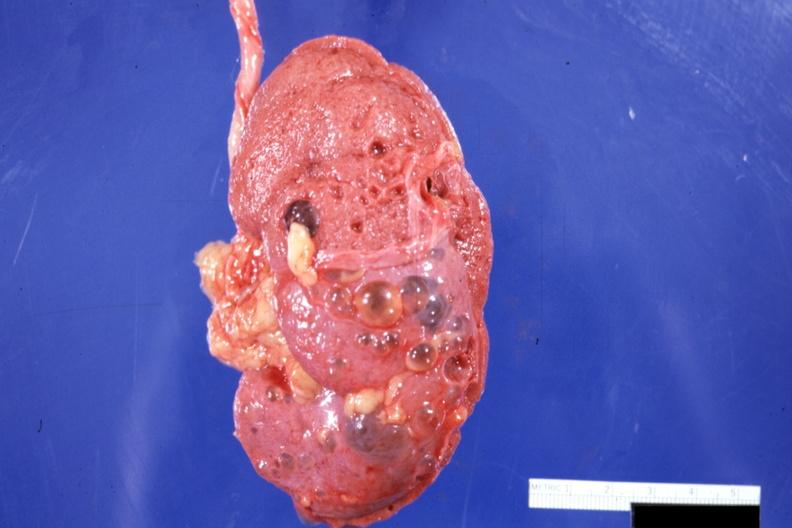what does this image show?
Answer the question using a single word or phrase. External view with capsule stripped 